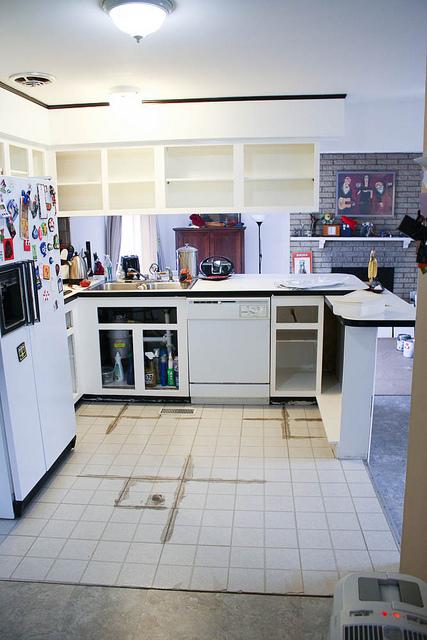What is on the refrigerator?
Be succinct. Magnets. Are there doors on the upper cabinets?
Answer briefly. No. Do they need a new floor?
Keep it brief. Yes. 